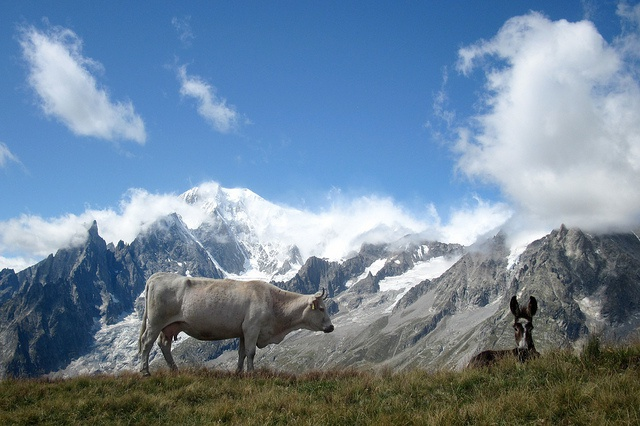Describe the objects in this image and their specific colors. I can see cow in gray, black, and darkgray tones and horse in gray and black tones in this image. 